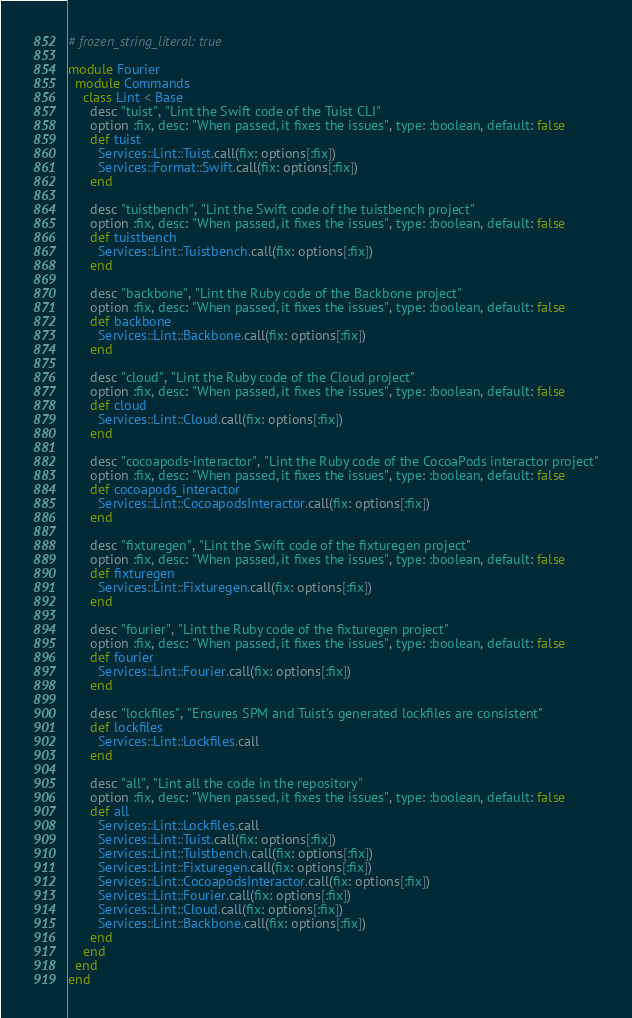<code> <loc_0><loc_0><loc_500><loc_500><_Ruby_># frozen_string_literal: true

module Fourier
  module Commands
    class Lint < Base
      desc "tuist", "Lint the Swift code of the Tuist CLI"
      option :fix, desc: "When passed, it fixes the issues", type: :boolean, default: false
      def tuist
        Services::Lint::Tuist.call(fix: options[:fix])
        Services::Format::Swift.call(fix: options[:fix])
      end

      desc "tuistbench", "Lint the Swift code of the tuistbench project"
      option :fix, desc: "When passed, it fixes the issues", type: :boolean, default: false
      def tuistbench
        Services::Lint::Tuistbench.call(fix: options[:fix])
      end

      desc "backbone", "Lint the Ruby code of the Backbone project"
      option :fix, desc: "When passed, it fixes the issues", type: :boolean, default: false
      def backbone
        Services::Lint::Backbone.call(fix: options[:fix])
      end

      desc "cloud", "Lint the Ruby code of the Cloud project"
      option :fix, desc: "When passed, it fixes the issues", type: :boolean, default: false
      def cloud
        Services::Lint::Cloud.call(fix: options[:fix])
      end

      desc "cocoapods-interactor", "Lint the Ruby code of the CocoaPods interactor project"
      option :fix, desc: "When passed, it fixes the issues", type: :boolean, default: false
      def cocoapods_interactor
        Services::Lint::CocoapodsInteractor.call(fix: options[:fix])
      end

      desc "fixturegen", "Lint the Swift code of the fixturegen project"
      option :fix, desc: "When passed, it fixes the issues", type: :boolean, default: false
      def fixturegen
        Services::Lint::Fixturegen.call(fix: options[:fix])
      end

      desc "fourier", "Lint the Ruby code of the fixturegen project"
      option :fix, desc: "When passed, it fixes the issues", type: :boolean, default: false
      def fourier
        Services::Lint::Fourier.call(fix: options[:fix])
      end

      desc "lockfiles", "Ensures SPM and Tuist's generated lockfiles are consistent"
      def lockfiles
        Services::Lint::Lockfiles.call
      end

      desc "all", "Lint all the code in the repository"
      option :fix, desc: "When passed, it fixes the issues", type: :boolean, default: false
      def all
        Services::Lint::Lockfiles.call
        Services::Lint::Tuist.call(fix: options[:fix])
        Services::Lint::Tuistbench.call(fix: options[:fix])
        Services::Lint::Fixturegen.call(fix: options[:fix])
        Services::Lint::CocoapodsInteractor.call(fix: options[:fix])
        Services::Lint::Fourier.call(fix: options[:fix])
        Services::Lint::Cloud.call(fix: options[:fix])
        Services::Lint::Backbone.call(fix: options[:fix])
      end
    end
  end
end
</code> 